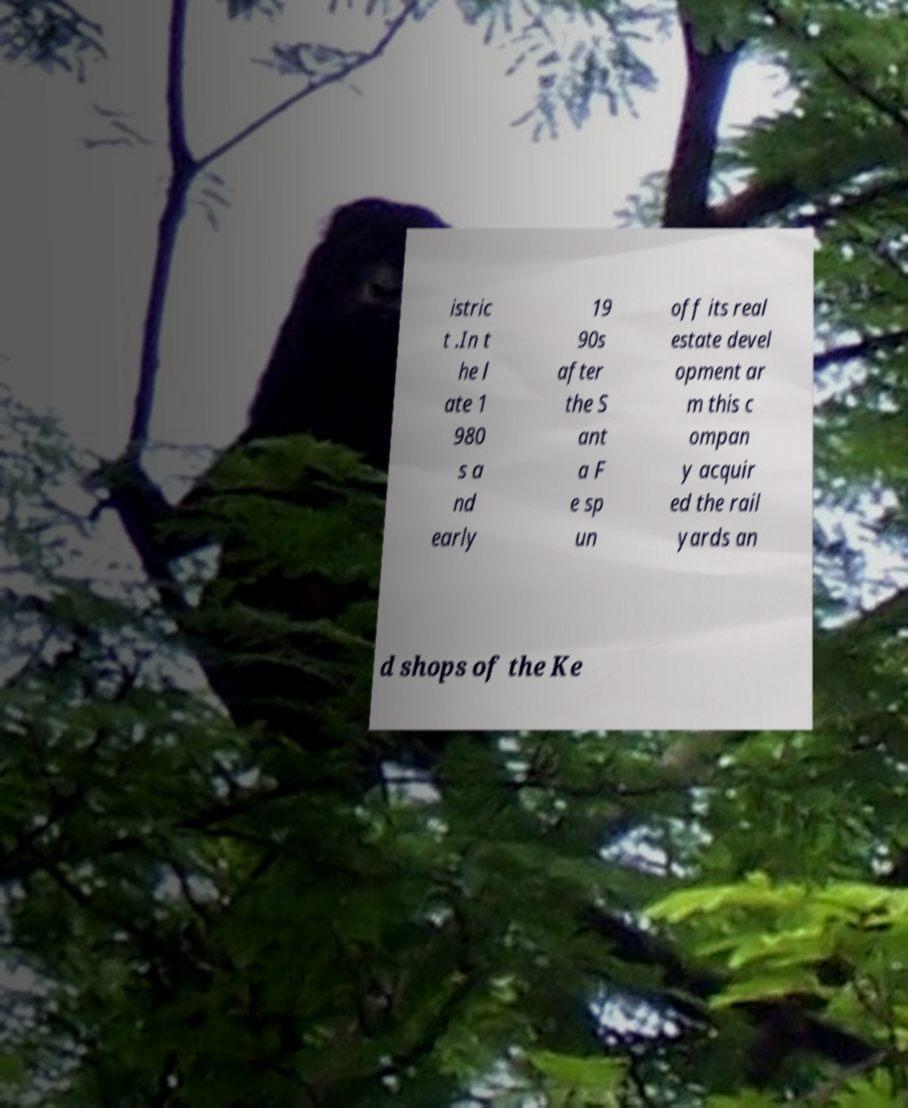For documentation purposes, I need the text within this image transcribed. Could you provide that? istric t .In t he l ate 1 980 s a nd early 19 90s after the S ant a F e sp un off its real estate devel opment ar m this c ompan y acquir ed the rail yards an d shops of the Ke 